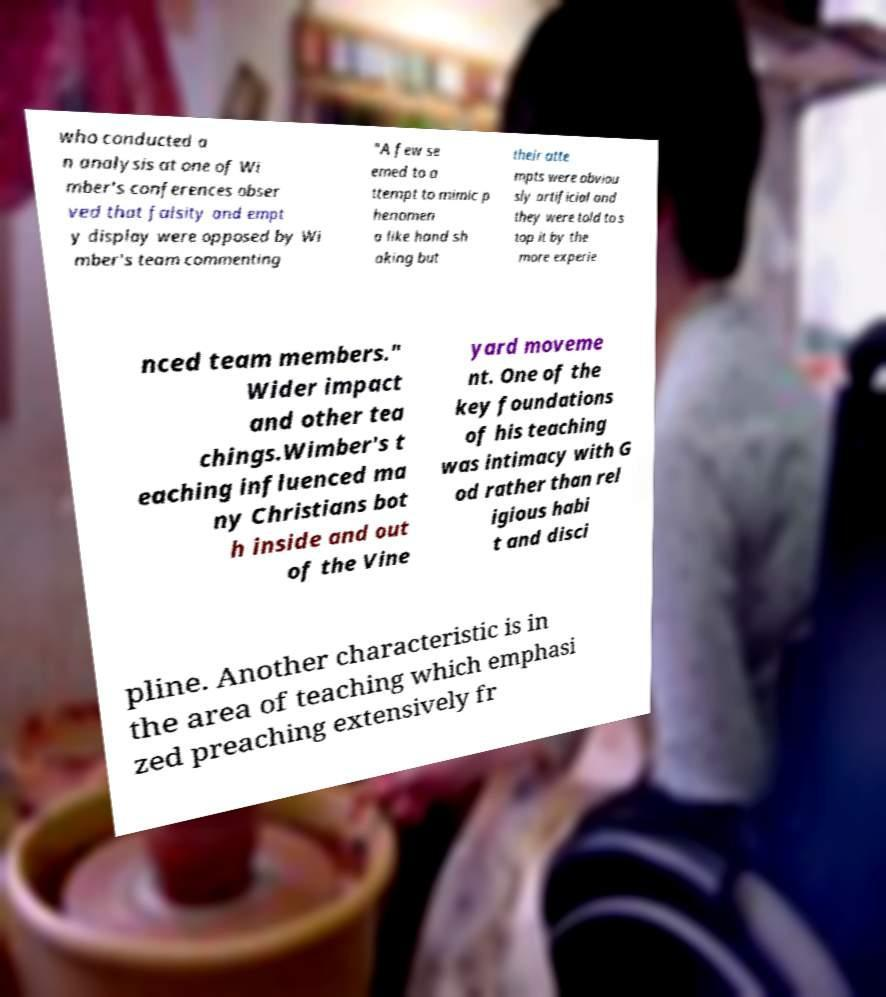What messages or text are displayed in this image? I need them in a readable, typed format. who conducted a n analysis at one of Wi mber's conferences obser ved that falsity and empt y display were opposed by Wi mber's team commenting "A few se emed to a ttempt to mimic p henomen a like hand sh aking but their atte mpts were obviou sly artificial and they were told to s top it by the more experie nced team members." Wider impact and other tea chings.Wimber's t eaching influenced ma ny Christians bot h inside and out of the Vine yard moveme nt. One of the key foundations of his teaching was intimacy with G od rather than rel igious habi t and disci pline. Another characteristic is in the area of teaching which emphasi zed preaching extensively fr 